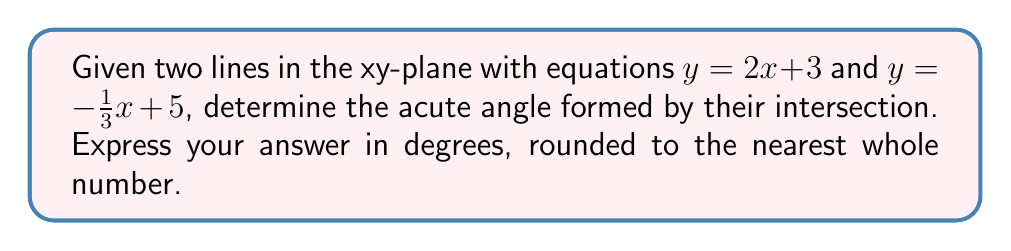Show me your answer to this math problem. To solve this problem, we'll follow these steps:

1. Recall that the angle between two lines can be calculated using their slopes:
   $$\tan \theta = \left|\frac{m_1 - m_2}{1 + m_1m_2}\right|$$
   where $m_1$ and $m_2$ are the slopes of the two lines.

2. Identify the slopes:
   For $y = 2x + 3$, $m_1 = 2$
   For $y = -\frac{1}{3}x + 5$, $m_2 = -\frac{1}{3}$

3. Substitute these values into the formula:
   $$\tan \theta = \left|\frac{2 - (-\frac{1}{3})}{1 + 2(-\frac{1}{3})}\right|$$

4. Simplify the numerator and denominator:
   $$\tan \theta = \left|\frac{2 + \frac{1}{3}}{1 - \frac{2}{3}}\right| = \left|\frac{\frac{7}{3}}{\frac{1}{3}}\right| = 7$$

5. To find $\theta$, we need to calculate the inverse tangent (arctangent):
   $$\theta = \arctan(7)$$

6. Convert the result to degrees:
   $$\theta \approx 81.87°$$

7. Round to the nearest whole number:
   $$\theta \approx 82°$$
Answer: 82° 